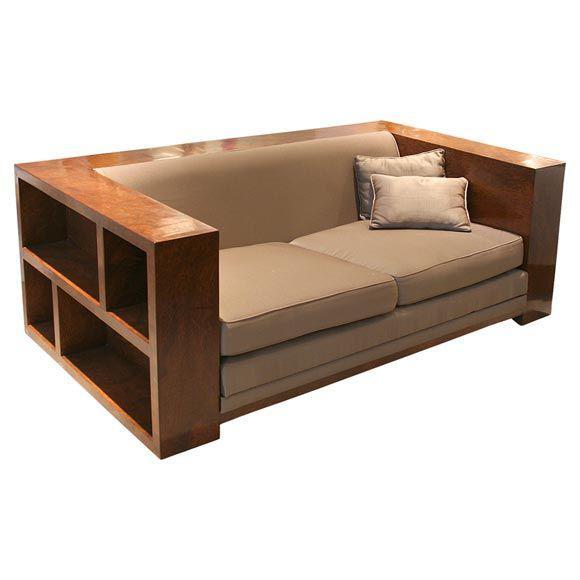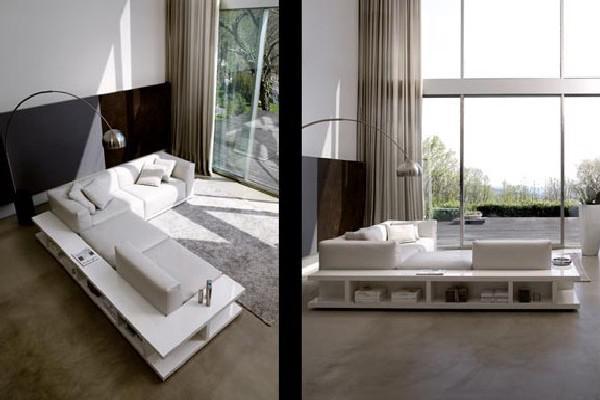The first image is the image on the left, the second image is the image on the right. Evaluate the accuracy of this statement regarding the images: "There is a stack of three books on the front-most corner of the shelf under the couch in the image on the left.". Is it true? Answer yes or no. No. 